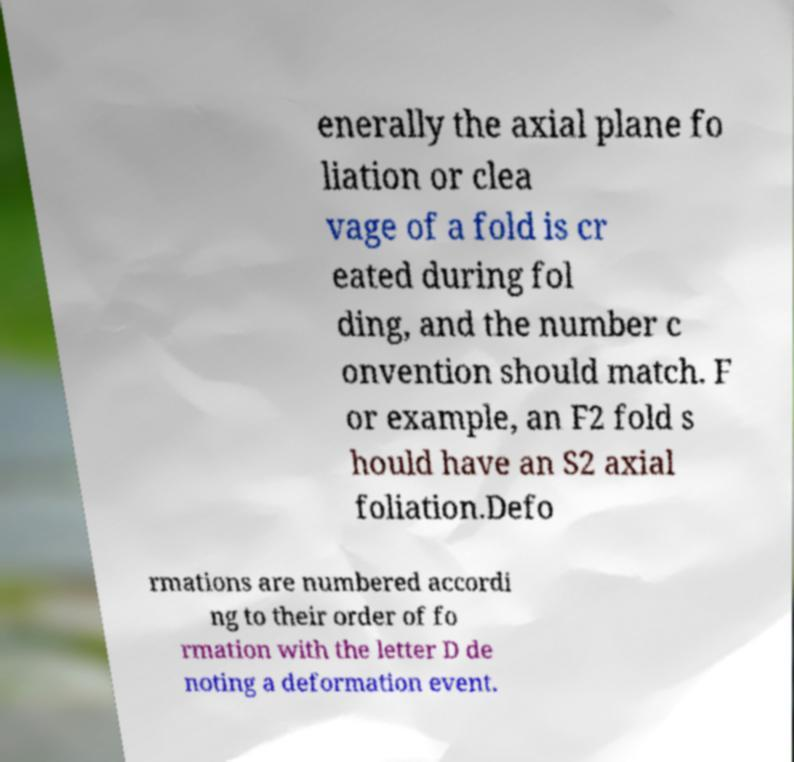Could you extract and type out the text from this image? enerally the axial plane fo liation or clea vage of a fold is cr eated during fol ding, and the number c onvention should match. F or example, an F2 fold s hould have an S2 axial foliation.Defo rmations are numbered accordi ng to their order of fo rmation with the letter D de noting a deformation event. 